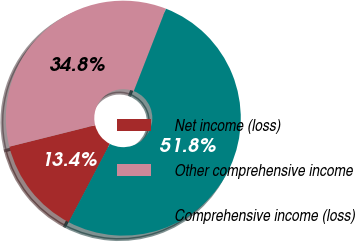<chart> <loc_0><loc_0><loc_500><loc_500><pie_chart><fcel>Net income (loss)<fcel>Other comprehensive income<fcel>Comprehensive income (loss)<nl><fcel>13.41%<fcel>34.82%<fcel>51.77%<nl></chart> 